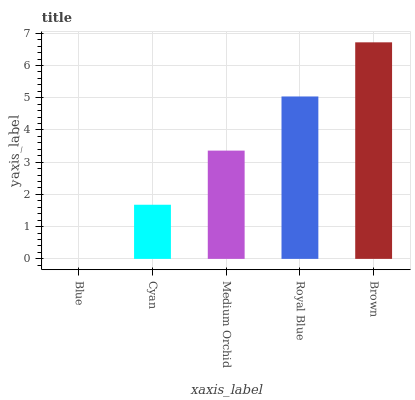Is Blue the minimum?
Answer yes or no. Yes. Is Brown the maximum?
Answer yes or no. Yes. Is Cyan the minimum?
Answer yes or no. No. Is Cyan the maximum?
Answer yes or no. No. Is Cyan greater than Blue?
Answer yes or no. Yes. Is Blue less than Cyan?
Answer yes or no. Yes. Is Blue greater than Cyan?
Answer yes or no. No. Is Cyan less than Blue?
Answer yes or no. No. Is Medium Orchid the high median?
Answer yes or no. Yes. Is Medium Orchid the low median?
Answer yes or no. Yes. Is Brown the high median?
Answer yes or no. No. Is Royal Blue the low median?
Answer yes or no. No. 